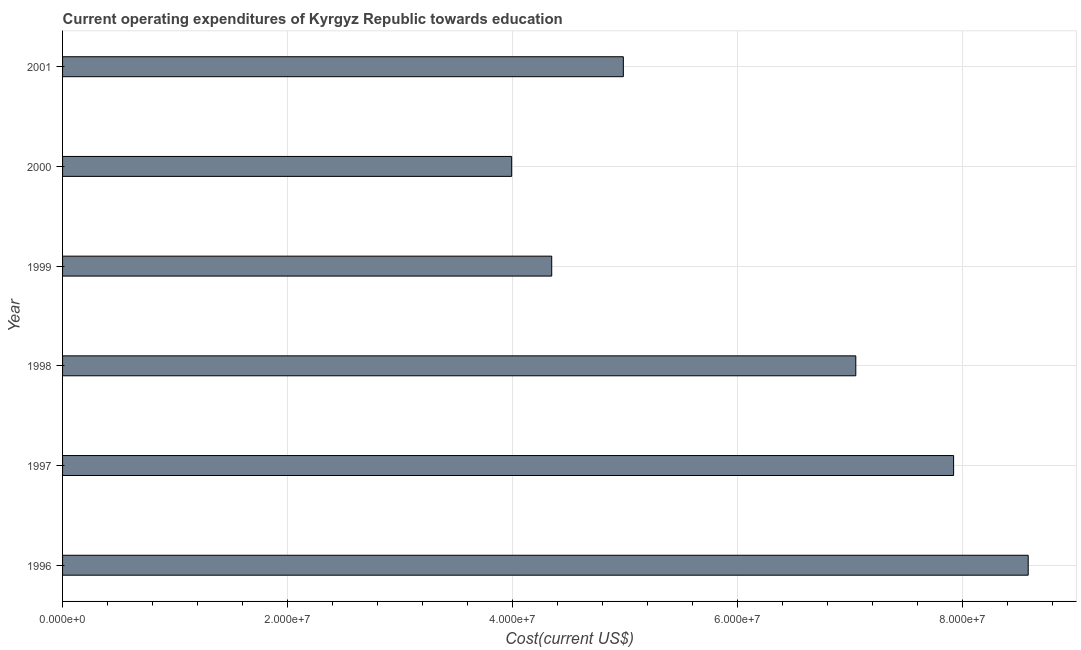Does the graph contain grids?
Give a very brief answer. Yes. What is the title of the graph?
Your answer should be very brief. Current operating expenditures of Kyrgyz Republic towards education. What is the label or title of the X-axis?
Offer a terse response. Cost(current US$). What is the education expenditure in 2000?
Offer a terse response. 3.99e+07. Across all years, what is the maximum education expenditure?
Provide a short and direct response. 8.58e+07. Across all years, what is the minimum education expenditure?
Your answer should be very brief. 3.99e+07. In which year was the education expenditure minimum?
Provide a short and direct response. 2000. What is the sum of the education expenditure?
Give a very brief answer. 3.69e+08. What is the difference between the education expenditure in 1998 and 2001?
Your answer should be very brief. 2.07e+07. What is the average education expenditure per year?
Give a very brief answer. 6.15e+07. What is the median education expenditure?
Make the answer very short. 6.02e+07. In how many years, is the education expenditure greater than 60000000 US$?
Make the answer very short. 3. What is the ratio of the education expenditure in 1999 to that in 2000?
Your answer should be very brief. 1.09. Is the education expenditure in 1996 less than that in 1997?
Your response must be concise. No. What is the difference between the highest and the second highest education expenditure?
Offer a very short reply. 6.63e+06. Is the sum of the education expenditure in 1999 and 2000 greater than the maximum education expenditure across all years?
Keep it short and to the point. No. What is the difference between the highest and the lowest education expenditure?
Offer a terse response. 4.59e+07. In how many years, is the education expenditure greater than the average education expenditure taken over all years?
Provide a short and direct response. 3. How many bars are there?
Offer a terse response. 6. Are all the bars in the graph horizontal?
Give a very brief answer. Yes. How many years are there in the graph?
Keep it short and to the point. 6. What is the Cost(current US$) in 1996?
Your response must be concise. 8.58e+07. What is the Cost(current US$) of 1997?
Give a very brief answer. 7.92e+07. What is the Cost(current US$) in 1998?
Offer a terse response. 7.05e+07. What is the Cost(current US$) of 1999?
Offer a terse response. 4.35e+07. What is the Cost(current US$) in 2000?
Your answer should be compact. 3.99e+07. What is the Cost(current US$) in 2001?
Provide a short and direct response. 4.98e+07. What is the difference between the Cost(current US$) in 1996 and 1997?
Your answer should be very brief. 6.63e+06. What is the difference between the Cost(current US$) in 1996 and 1998?
Ensure brevity in your answer.  1.53e+07. What is the difference between the Cost(current US$) in 1996 and 1999?
Make the answer very short. 4.24e+07. What is the difference between the Cost(current US$) in 1996 and 2000?
Provide a succinct answer. 4.59e+07. What is the difference between the Cost(current US$) in 1996 and 2001?
Your answer should be compact. 3.60e+07. What is the difference between the Cost(current US$) in 1997 and 1998?
Your answer should be very brief. 8.69e+06. What is the difference between the Cost(current US$) in 1997 and 1999?
Give a very brief answer. 3.57e+07. What is the difference between the Cost(current US$) in 1997 and 2000?
Offer a very short reply. 3.93e+07. What is the difference between the Cost(current US$) in 1997 and 2001?
Ensure brevity in your answer.  2.94e+07. What is the difference between the Cost(current US$) in 1998 and 1999?
Offer a terse response. 2.70e+07. What is the difference between the Cost(current US$) in 1998 and 2000?
Offer a terse response. 3.06e+07. What is the difference between the Cost(current US$) in 1998 and 2001?
Keep it short and to the point. 2.07e+07. What is the difference between the Cost(current US$) in 1999 and 2000?
Provide a succinct answer. 3.56e+06. What is the difference between the Cost(current US$) in 1999 and 2001?
Your answer should be very brief. -6.37e+06. What is the difference between the Cost(current US$) in 2000 and 2001?
Offer a terse response. -9.93e+06. What is the ratio of the Cost(current US$) in 1996 to that in 1997?
Your answer should be compact. 1.08. What is the ratio of the Cost(current US$) in 1996 to that in 1998?
Offer a very short reply. 1.22. What is the ratio of the Cost(current US$) in 1996 to that in 1999?
Ensure brevity in your answer.  1.97. What is the ratio of the Cost(current US$) in 1996 to that in 2000?
Provide a short and direct response. 2.15. What is the ratio of the Cost(current US$) in 1996 to that in 2001?
Keep it short and to the point. 1.72. What is the ratio of the Cost(current US$) in 1997 to that in 1998?
Keep it short and to the point. 1.12. What is the ratio of the Cost(current US$) in 1997 to that in 1999?
Offer a very short reply. 1.82. What is the ratio of the Cost(current US$) in 1997 to that in 2000?
Give a very brief answer. 1.98. What is the ratio of the Cost(current US$) in 1997 to that in 2001?
Provide a succinct answer. 1.59. What is the ratio of the Cost(current US$) in 1998 to that in 1999?
Ensure brevity in your answer.  1.62. What is the ratio of the Cost(current US$) in 1998 to that in 2000?
Give a very brief answer. 1.77. What is the ratio of the Cost(current US$) in 1998 to that in 2001?
Keep it short and to the point. 1.42. What is the ratio of the Cost(current US$) in 1999 to that in 2000?
Provide a short and direct response. 1.09. What is the ratio of the Cost(current US$) in 1999 to that in 2001?
Your answer should be very brief. 0.87. What is the ratio of the Cost(current US$) in 2000 to that in 2001?
Your answer should be compact. 0.8. 